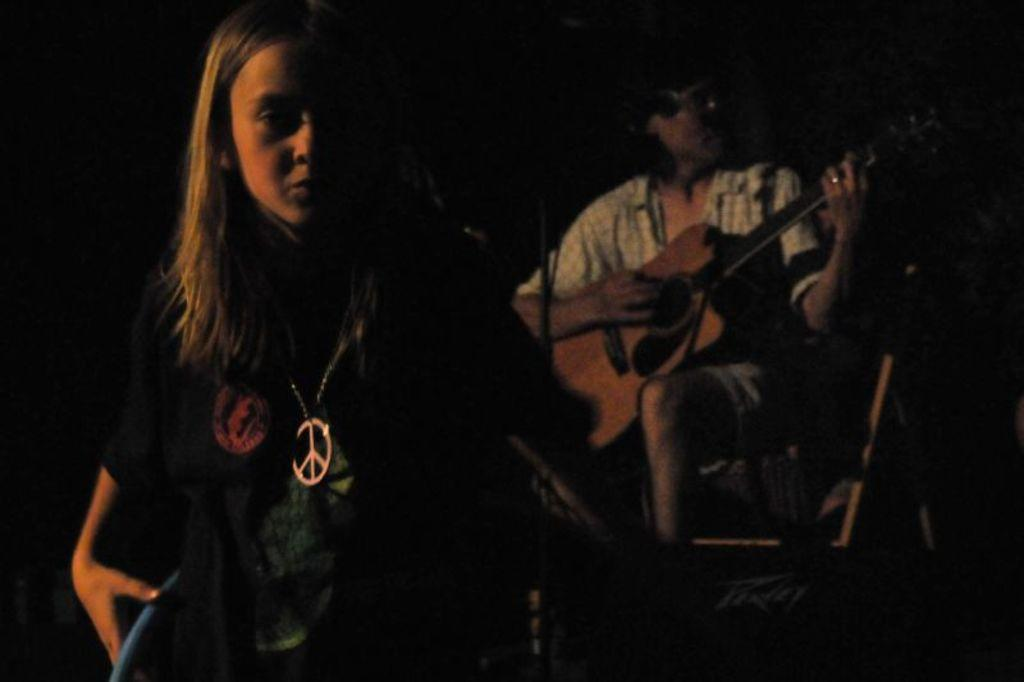What is the person in the image wearing? The person in the image is wearing a white shirt. What is the person doing while wearing the white shirt? The person is sitting and playing a guitar. Is there anyone else in the image besides the person playing the guitar? Yes, there is another person standing in front of the person playing the guitar. What type of meat is the person holding in the image? There is no meat present in the image; the person is playing a guitar. 